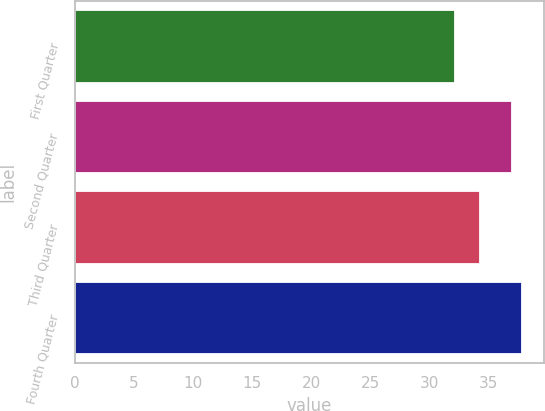<chart> <loc_0><loc_0><loc_500><loc_500><bar_chart><fcel>First Quarter<fcel>Second Quarter<fcel>Third Quarter<fcel>Fourth Quarter<nl><fcel>32.18<fcel>36.95<fcel>34.25<fcel>37.82<nl></chart> 